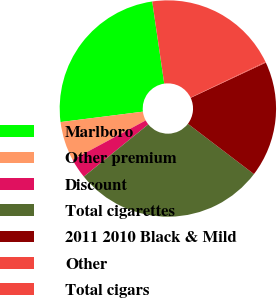Convert chart. <chart><loc_0><loc_0><loc_500><loc_500><pie_chart><fcel>Marlboro<fcel>Other premium<fcel>Discount<fcel>Total cigarettes<fcel>2011 2010 Black & Mild<fcel>Other<fcel>Total cigars<nl><fcel>24.69%<fcel>5.85%<fcel>2.99%<fcel>28.8%<fcel>17.34%<fcel>0.12%<fcel>20.21%<nl></chart> 